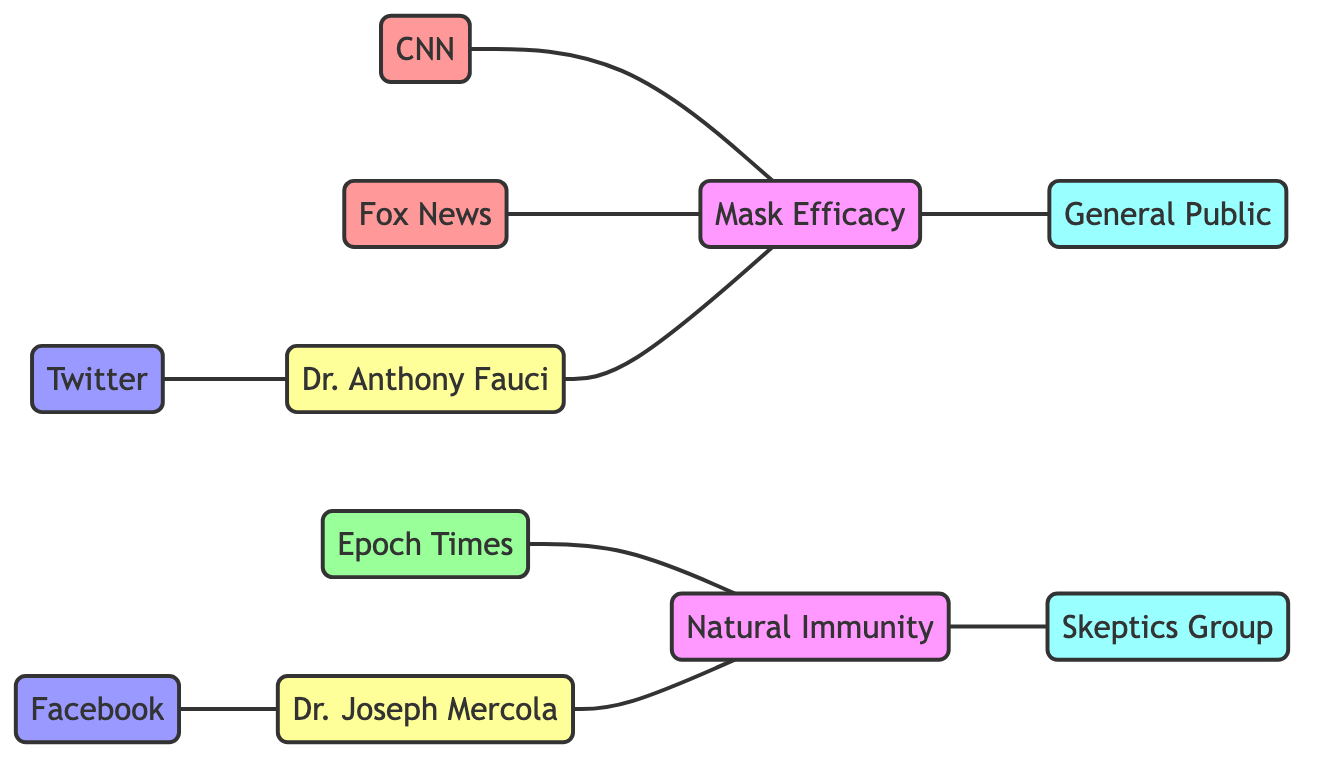What is the total number of media outlets in the diagram? The diagram contains three media outlets: CNN, Fox News, and Epoch Times. By counting these nodes, we find that the total is 3.
Answer: 3 Which topic is associated with CNN? The edge connecting CNN to the topic indicates that CNN covers the topic of Mask Efficacy. This direct relationship is shown in the diagram.
Answer: Mask Efficacy Who endorses Natural Immunity? The diagram shows an edge connecting Dr. Joseph Mercola to the topic of Natural Immunity, indicating that he endorses it. Thus, Dr. Joseph Mercola is the answer.
Answer: Dr. Joseph Mercola What is the label of the audience influenced by Mask Efficacy? The diagram shows an edge that connects Mask Efficacy to the General Public audience, indicating that this audience is influenced by the topic of Mask Efficacy.
Answer: General Public Which social media platform is linked to Dr. Anthony Fauci? The link in the diagram shows that Twitter is the social media platform connected to Dr. Anthony Fauci, indicating this platform serves as a platform for him.
Answer: Twitter How many edges are related to the topic of Natural Immunity? The diagram shows two edges related to Natural Immunity: one connecting Epoch Times and another connecting it to the Skeptics Group. Thus, the count of these edges is 2.
Answer: 2 Which media outlet primarily promotes Natural Immunity? The diagram indicates that Epoch Times is promoting the topic of Natural Immunity by showing a direct edge between the two.
Answer: Epoch Times What audience does Dr. Anthony Fauci influence? The diagram connects Dr. Anthony Fauci to the topic of Mask Efficacy, which in turn influences the General Public. Hence, he influences the General Public indirectly through this connection.
Answer: General Public 